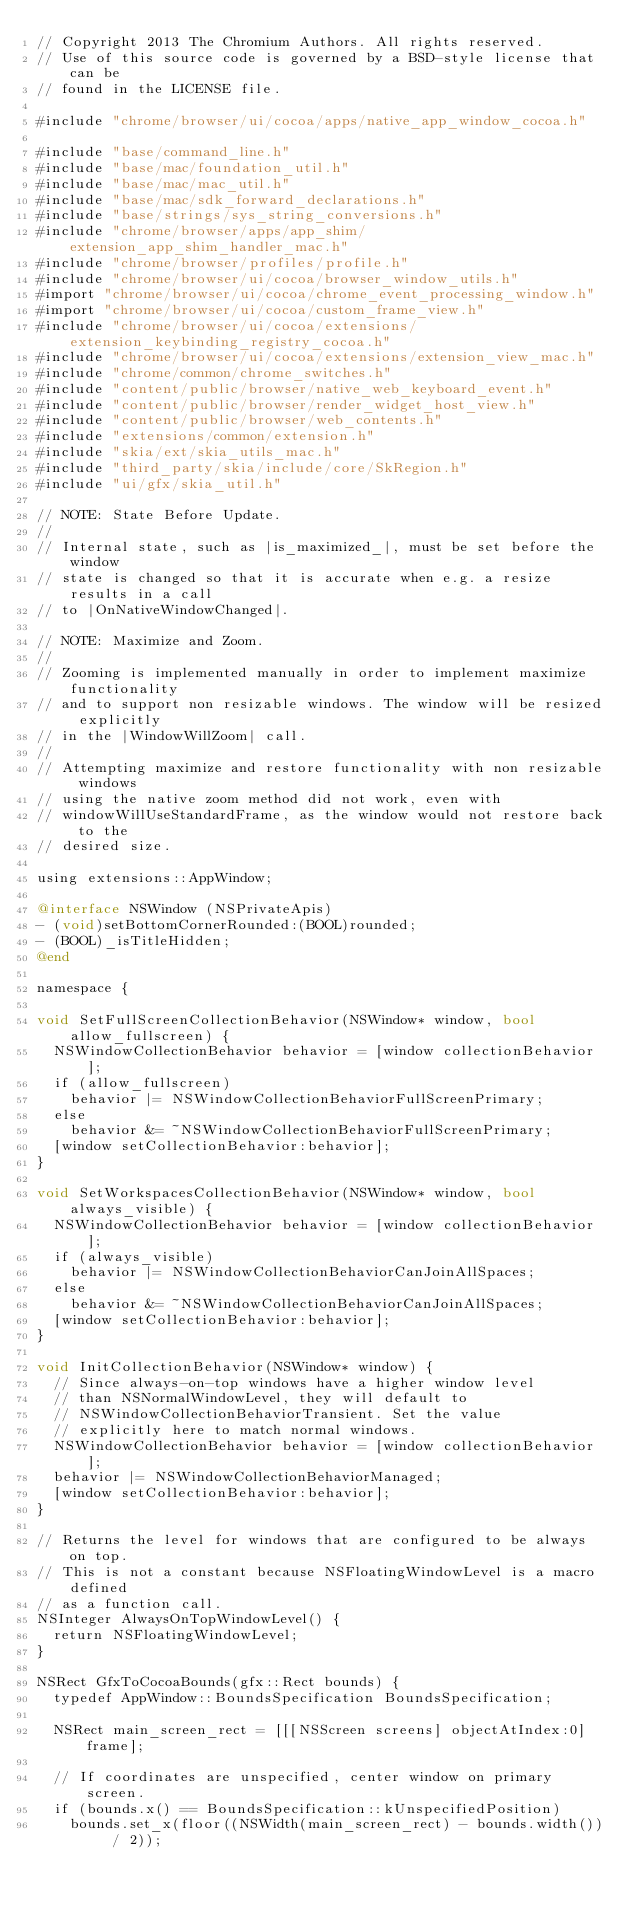Convert code to text. <code><loc_0><loc_0><loc_500><loc_500><_ObjectiveC_>// Copyright 2013 The Chromium Authors. All rights reserved.
// Use of this source code is governed by a BSD-style license that can be
// found in the LICENSE file.

#include "chrome/browser/ui/cocoa/apps/native_app_window_cocoa.h"

#include "base/command_line.h"
#include "base/mac/foundation_util.h"
#include "base/mac/mac_util.h"
#include "base/mac/sdk_forward_declarations.h"
#include "base/strings/sys_string_conversions.h"
#include "chrome/browser/apps/app_shim/extension_app_shim_handler_mac.h"
#include "chrome/browser/profiles/profile.h"
#include "chrome/browser/ui/cocoa/browser_window_utils.h"
#import "chrome/browser/ui/cocoa/chrome_event_processing_window.h"
#import "chrome/browser/ui/cocoa/custom_frame_view.h"
#include "chrome/browser/ui/cocoa/extensions/extension_keybinding_registry_cocoa.h"
#include "chrome/browser/ui/cocoa/extensions/extension_view_mac.h"
#include "chrome/common/chrome_switches.h"
#include "content/public/browser/native_web_keyboard_event.h"
#include "content/public/browser/render_widget_host_view.h"
#include "content/public/browser/web_contents.h"
#include "extensions/common/extension.h"
#include "skia/ext/skia_utils_mac.h"
#include "third_party/skia/include/core/SkRegion.h"
#include "ui/gfx/skia_util.h"

// NOTE: State Before Update.
//
// Internal state, such as |is_maximized_|, must be set before the window
// state is changed so that it is accurate when e.g. a resize results in a call
// to |OnNativeWindowChanged|.

// NOTE: Maximize and Zoom.
//
// Zooming is implemented manually in order to implement maximize functionality
// and to support non resizable windows. The window will be resized explicitly
// in the |WindowWillZoom| call.
//
// Attempting maximize and restore functionality with non resizable windows
// using the native zoom method did not work, even with
// windowWillUseStandardFrame, as the window would not restore back to the
// desired size.

using extensions::AppWindow;

@interface NSWindow (NSPrivateApis)
- (void)setBottomCornerRounded:(BOOL)rounded;
- (BOOL)_isTitleHidden;
@end

namespace {

void SetFullScreenCollectionBehavior(NSWindow* window, bool allow_fullscreen) {
  NSWindowCollectionBehavior behavior = [window collectionBehavior];
  if (allow_fullscreen)
    behavior |= NSWindowCollectionBehaviorFullScreenPrimary;
  else
    behavior &= ~NSWindowCollectionBehaviorFullScreenPrimary;
  [window setCollectionBehavior:behavior];
}

void SetWorkspacesCollectionBehavior(NSWindow* window, bool always_visible) {
  NSWindowCollectionBehavior behavior = [window collectionBehavior];
  if (always_visible)
    behavior |= NSWindowCollectionBehaviorCanJoinAllSpaces;
  else
    behavior &= ~NSWindowCollectionBehaviorCanJoinAllSpaces;
  [window setCollectionBehavior:behavior];
}

void InitCollectionBehavior(NSWindow* window) {
  // Since always-on-top windows have a higher window level
  // than NSNormalWindowLevel, they will default to
  // NSWindowCollectionBehaviorTransient. Set the value
  // explicitly here to match normal windows.
  NSWindowCollectionBehavior behavior = [window collectionBehavior];
  behavior |= NSWindowCollectionBehaviorManaged;
  [window setCollectionBehavior:behavior];
}

// Returns the level for windows that are configured to be always on top.
// This is not a constant because NSFloatingWindowLevel is a macro defined
// as a function call.
NSInteger AlwaysOnTopWindowLevel() {
  return NSFloatingWindowLevel;
}

NSRect GfxToCocoaBounds(gfx::Rect bounds) {
  typedef AppWindow::BoundsSpecification BoundsSpecification;

  NSRect main_screen_rect = [[[NSScreen screens] objectAtIndex:0] frame];

  // If coordinates are unspecified, center window on primary screen.
  if (bounds.x() == BoundsSpecification::kUnspecifiedPosition)
    bounds.set_x(floor((NSWidth(main_screen_rect) - bounds.width()) / 2));</code> 